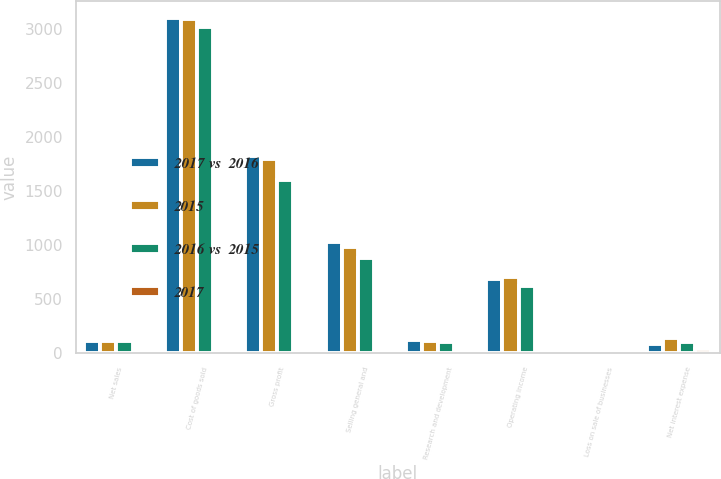<chart> <loc_0><loc_0><loc_500><loc_500><stacked_bar_chart><ecel><fcel>Net sales<fcel>Cost of goods sold<fcel>Gross profit<fcel>Selling general and<fcel>Research and development<fcel>Operating income<fcel>Loss on sale of businesses<fcel>Net interest expense<nl><fcel>2017 vs  2016<fcel>114.1<fcel>3107.4<fcel>1829.1<fcel>1032.5<fcel>115.8<fcel>680.8<fcel>4.2<fcel>87.3<nl><fcel>2015<fcel>114.1<fcel>3095.9<fcel>1794.1<fcel>979.3<fcel>114.1<fcel>700.7<fcel>3.9<fcel>140.1<nl><fcel>2016 vs  2015<fcel>114.1<fcel>3017.6<fcel>1598.8<fcel>884<fcel>98.7<fcel>616.1<fcel>3.2<fcel>101.9<nl><fcel>2017<fcel>1<fcel>0.4<fcel>2<fcel>5.4<fcel>1.5<fcel>2.8<fcel>7.7<fcel>37.7<nl></chart> 